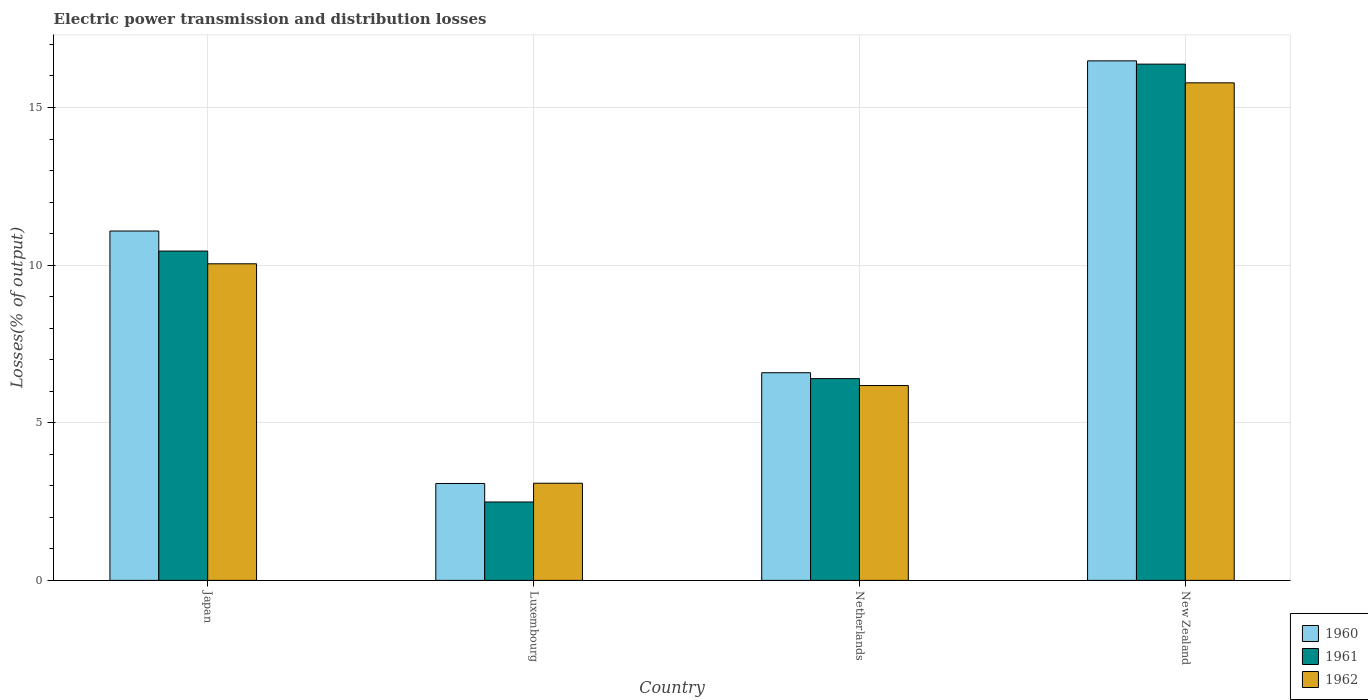How many different coloured bars are there?
Provide a short and direct response. 3. Are the number of bars per tick equal to the number of legend labels?
Your answer should be very brief. Yes. Are the number of bars on each tick of the X-axis equal?
Provide a short and direct response. Yes. How many bars are there on the 3rd tick from the left?
Your answer should be very brief. 3. How many bars are there on the 1st tick from the right?
Provide a short and direct response. 3. What is the label of the 2nd group of bars from the left?
Give a very brief answer. Luxembourg. What is the electric power transmission and distribution losses in 1960 in Japan?
Make the answer very short. 11.08. Across all countries, what is the maximum electric power transmission and distribution losses in 1962?
Offer a terse response. 15.78. Across all countries, what is the minimum electric power transmission and distribution losses in 1961?
Your answer should be compact. 2.49. In which country was the electric power transmission and distribution losses in 1962 maximum?
Your answer should be compact. New Zealand. In which country was the electric power transmission and distribution losses in 1962 minimum?
Keep it short and to the point. Luxembourg. What is the total electric power transmission and distribution losses in 1961 in the graph?
Give a very brief answer. 35.71. What is the difference between the electric power transmission and distribution losses in 1960 in Luxembourg and that in Netherlands?
Ensure brevity in your answer.  -3.51. What is the difference between the electric power transmission and distribution losses in 1961 in New Zealand and the electric power transmission and distribution losses in 1960 in Luxembourg?
Make the answer very short. 13.3. What is the average electric power transmission and distribution losses in 1961 per country?
Make the answer very short. 8.93. What is the difference between the electric power transmission and distribution losses of/in 1961 and electric power transmission and distribution losses of/in 1960 in Japan?
Give a very brief answer. -0.64. In how many countries, is the electric power transmission and distribution losses in 1961 greater than 1 %?
Ensure brevity in your answer.  4. What is the ratio of the electric power transmission and distribution losses in 1960 in Luxembourg to that in Netherlands?
Your answer should be very brief. 0.47. Is the electric power transmission and distribution losses in 1961 in Luxembourg less than that in Netherlands?
Provide a short and direct response. Yes. What is the difference between the highest and the second highest electric power transmission and distribution losses in 1961?
Provide a short and direct response. 5.93. What is the difference between the highest and the lowest electric power transmission and distribution losses in 1961?
Keep it short and to the point. 13.89. In how many countries, is the electric power transmission and distribution losses in 1960 greater than the average electric power transmission and distribution losses in 1960 taken over all countries?
Your answer should be compact. 2. Is it the case that in every country, the sum of the electric power transmission and distribution losses in 1960 and electric power transmission and distribution losses in 1962 is greater than the electric power transmission and distribution losses in 1961?
Offer a terse response. Yes. How many bars are there?
Provide a succinct answer. 12. Are all the bars in the graph horizontal?
Provide a short and direct response. No. Are the values on the major ticks of Y-axis written in scientific E-notation?
Provide a succinct answer. No. Does the graph contain grids?
Make the answer very short. Yes. Where does the legend appear in the graph?
Provide a succinct answer. Bottom right. How are the legend labels stacked?
Offer a terse response. Vertical. What is the title of the graph?
Give a very brief answer. Electric power transmission and distribution losses. What is the label or title of the X-axis?
Ensure brevity in your answer.  Country. What is the label or title of the Y-axis?
Offer a very short reply. Losses(% of output). What is the Losses(% of output) of 1960 in Japan?
Offer a terse response. 11.08. What is the Losses(% of output) of 1961 in Japan?
Make the answer very short. 10.45. What is the Losses(% of output) of 1962 in Japan?
Your response must be concise. 10.04. What is the Losses(% of output) in 1960 in Luxembourg?
Offer a very short reply. 3.07. What is the Losses(% of output) of 1961 in Luxembourg?
Give a very brief answer. 2.49. What is the Losses(% of output) of 1962 in Luxembourg?
Your answer should be compact. 3.08. What is the Losses(% of output) in 1960 in Netherlands?
Keep it short and to the point. 6.59. What is the Losses(% of output) in 1961 in Netherlands?
Give a very brief answer. 6.4. What is the Losses(% of output) in 1962 in Netherlands?
Give a very brief answer. 6.18. What is the Losses(% of output) in 1960 in New Zealand?
Give a very brief answer. 16.48. What is the Losses(% of output) in 1961 in New Zealand?
Give a very brief answer. 16.38. What is the Losses(% of output) in 1962 in New Zealand?
Your response must be concise. 15.78. Across all countries, what is the maximum Losses(% of output) in 1960?
Give a very brief answer. 16.48. Across all countries, what is the maximum Losses(% of output) of 1961?
Ensure brevity in your answer.  16.38. Across all countries, what is the maximum Losses(% of output) in 1962?
Offer a very short reply. 15.78. Across all countries, what is the minimum Losses(% of output) of 1960?
Provide a succinct answer. 3.07. Across all countries, what is the minimum Losses(% of output) in 1961?
Keep it short and to the point. 2.49. Across all countries, what is the minimum Losses(% of output) in 1962?
Your answer should be compact. 3.08. What is the total Losses(% of output) of 1960 in the graph?
Ensure brevity in your answer.  37.22. What is the total Losses(% of output) of 1961 in the graph?
Your answer should be very brief. 35.71. What is the total Losses(% of output) in 1962 in the graph?
Your answer should be compact. 35.09. What is the difference between the Losses(% of output) in 1960 in Japan and that in Luxembourg?
Your answer should be very brief. 8.01. What is the difference between the Losses(% of output) in 1961 in Japan and that in Luxembourg?
Keep it short and to the point. 7.96. What is the difference between the Losses(% of output) in 1962 in Japan and that in Luxembourg?
Your response must be concise. 6.96. What is the difference between the Losses(% of output) of 1960 in Japan and that in Netherlands?
Offer a terse response. 4.49. What is the difference between the Losses(% of output) in 1961 in Japan and that in Netherlands?
Your response must be concise. 4.05. What is the difference between the Losses(% of output) of 1962 in Japan and that in Netherlands?
Ensure brevity in your answer.  3.86. What is the difference between the Losses(% of output) in 1960 in Japan and that in New Zealand?
Offer a terse response. -5.4. What is the difference between the Losses(% of output) of 1961 in Japan and that in New Zealand?
Make the answer very short. -5.93. What is the difference between the Losses(% of output) in 1962 in Japan and that in New Zealand?
Provide a succinct answer. -5.74. What is the difference between the Losses(% of output) in 1960 in Luxembourg and that in Netherlands?
Your response must be concise. -3.51. What is the difference between the Losses(% of output) of 1961 in Luxembourg and that in Netherlands?
Offer a terse response. -3.91. What is the difference between the Losses(% of output) of 1962 in Luxembourg and that in Netherlands?
Keep it short and to the point. -3.1. What is the difference between the Losses(% of output) in 1960 in Luxembourg and that in New Zealand?
Your answer should be compact. -13.41. What is the difference between the Losses(% of output) in 1961 in Luxembourg and that in New Zealand?
Your response must be concise. -13.89. What is the difference between the Losses(% of output) of 1962 in Luxembourg and that in New Zealand?
Provide a succinct answer. -12.7. What is the difference between the Losses(% of output) in 1960 in Netherlands and that in New Zealand?
Provide a succinct answer. -9.89. What is the difference between the Losses(% of output) in 1961 in Netherlands and that in New Zealand?
Make the answer very short. -9.98. What is the difference between the Losses(% of output) in 1962 in Netherlands and that in New Zealand?
Give a very brief answer. -9.6. What is the difference between the Losses(% of output) in 1960 in Japan and the Losses(% of output) in 1961 in Luxembourg?
Provide a short and direct response. 8.6. What is the difference between the Losses(% of output) of 1960 in Japan and the Losses(% of output) of 1962 in Luxembourg?
Keep it short and to the point. 8. What is the difference between the Losses(% of output) in 1961 in Japan and the Losses(% of output) in 1962 in Luxembourg?
Your answer should be very brief. 7.36. What is the difference between the Losses(% of output) of 1960 in Japan and the Losses(% of output) of 1961 in Netherlands?
Ensure brevity in your answer.  4.68. What is the difference between the Losses(% of output) in 1960 in Japan and the Losses(% of output) in 1962 in Netherlands?
Provide a short and direct response. 4.9. What is the difference between the Losses(% of output) of 1961 in Japan and the Losses(% of output) of 1962 in Netherlands?
Give a very brief answer. 4.27. What is the difference between the Losses(% of output) in 1960 in Japan and the Losses(% of output) in 1961 in New Zealand?
Offer a very short reply. -5.29. What is the difference between the Losses(% of output) of 1960 in Japan and the Losses(% of output) of 1962 in New Zealand?
Ensure brevity in your answer.  -4.7. What is the difference between the Losses(% of output) of 1961 in Japan and the Losses(% of output) of 1962 in New Zealand?
Your answer should be very brief. -5.34. What is the difference between the Losses(% of output) of 1960 in Luxembourg and the Losses(% of output) of 1961 in Netherlands?
Give a very brief answer. -3.33. What is the difference between the Losses(% of output) in 1960 in Luxembourg and the Losses(% of output) in 1962 in Netherlands?
Offer a very short reply. -3.11. What is the difference between the Losses(% of output) of 1961 in Luxembourg and the Losses(% of output) of 1962 in Netherlands?
Your answer should be compact. -3.69. What is the difference between the Losses(% of output) in 1960 in Luxembourg and the Losses(% of output) in 1961 in New Zealand?
Provide a succinct answer. -13.3. What is the difference between the Losses(% of output) in 1960 in Luxembourg and the Losses(% of output) in 1962 in New Zealand?
Keep it short and to the point. -12.71. What is the difference between the Losses(% of output) of 1961 in Luxembourg and the Losses(% of output) of 1962 in New Zealand?
Provide a short and direct response. -13.3. What is the difference between the Losses(% of output) in 1960 in Netherlands and the Losses(% of output) in 1961 in New Zealand?
Your answer should be very brief. -9.79. What is the difference between the Losses(% of output) in 1960 in Netherlands and the Losses(% of output) in 1962 in New Zealand?
Make the answer very short. -9.2. What is the difference between the Losses(% of output) of 1961 in Netherlands and the Losses(% of output) of 1962 in New Zealand?
Provide a succinct answer. -9.38. What is the average Losses(% of output) of 1960 per country?
Your answer should be very brief. 9.31. What is the average Losses(% of output) in 1961 per country?
Make the answer very short. 8.93. What is the average Losses(% of output) of 1962 per country?
Provide a short and direct response. 8.77. What is the difference between the Losses(% of output) in 1960 and Losses(% of output) in 1961 in Japan?
Ensure brevity in your answer.  0.64. What is the difference between the Losses(% of output) in 1960 and Losses(% of output) in 1962 in Japan?
Give a very brief answer. 1.04. What is the difference between the Losses(% of output) of 1961 and Losses(% of output) of 1962 in Japan?
Your answer should be very brief. 0.4. What is the difference between the Losses(% of output) in 1960 and Losses(% of output) in 1961 in Luxembourg?
Keep it short and to the point. 0.59. What is the difference between the Losses(% of output) in 1960 and Losses(% of output) in 1962 in Luxembourg?
Offer a very short reply. -0.01. What is the difference between the Losses(% of output) in 1961 and Losses(% of output) in 1962 in Luxembourg?
Your answer should be very brief. -0.6. What is the difference between the Losses(% of output) in 1960 and Losses(% of output) in 1961 in Netherlands?
Offer a very short reply. 0.19. What is the difference between the Losses(% of output) in 1960 and Losses(% of output) in 1962 in Netherlands?
Your answer should be compact. 0.41. What is the difference between the Losses(% of output) in 1961 and Losses(% of output) in 1962 in Netherlands?
Offer a terse response. 0.22. What is the difference between the Losses(% of output) of 1960 and Losses(% of output) of 1961 in New Zealand?
Ensure brevity in your answer.  0.1. What is the difference between the Losses(% of output) in 1960 and Losses(% of output) in 1962 in New Zealand?
Ensure brevity in your answer.  0.7. What is the difference between the Losses(% of output) in 1961 and Losses(% of output) in 1962 in New Zealand?
Provide a succinct answer. 0.59. What is the ratio of the Losses(% of output) of 1960 in Japan to that in Luxembourg?
Your answer should be very brief. 3.61. What is the ratio of the Losses(% of output) of 1961 in Japan to that in Luxembourg?
Your answer should be compact. 4.2. What is the ratio of the Losses(% of output) in 1962 in Japan to that in Luxembourg?
Ensure brevity in your answer.  3.26. What is the ratio of the Losses(% of output) in 1960 in Japan to that in Netherlands?
Give a very brief answer. 1.68. What is the ratio of the Losses(% of output) in 1961 in Japan to that in Netherlands?
Your answer should be compact. 1.63. What is the ratio of the Losses(% of output) in 1962 in Japan to that in Netherlands?
Provide a succinct answer. 1.62. What is the ratio of the Losses(% of output) in 1960 in Japan to that in New Zealand?
Provide a short and direct response. 0.67. What is the ratio of the Losses(% of output) in 1961 in Japan to that in New Zealand?
Provide a short and direct response. 0.64. What is the ratio of the Losses(% of output) of 1962 in Japan to that in New Zealand?
Offer a terse response. 0.64. What is the ratio of the Losses(% of output) in 1960 in Luxembourg to that in Netherlands?
Your answer should be very brief. 0.47. What is the ratio of the Losses(% of output) of 1961 in Luxembourg to that in Netherlands?
Provide a short and direct response. 0.39. What is the ratio of the Losses(% of output) of 1962 in Luxembourg to that in Netherlands?
Your response must be concise. 0.5. What is the ratio of the Losses(% of output) in 1960 in Luxembourg to that in New Zealand?
Give a very brief answer. 0.19. What is the ratio of the Losses(% of output) in 1961 in Luxembourg to that in New Zealand?
Keep it short and to the point. 0.15. What is the ratio of the Losses(% of output) of 1962 in Luxembourg to that in New Zealand?
Offer a very short reply. 0.2. What is the ratio of the Losses(% of output) in 1960 in Netherlands to that in New Zealand?
Keep it short and to the point. 0.4. What is the ratio of the Losses(% of output) of 1961 in Netherlands to that in New Zealand?
Make the answer very short. 0.39. What is the ratio of the Losses(% of output) of 1962 in Netherlands to that in New Zealand?
Your answer should be compact. 0.39. What is the difference between the highest and the second highest Losses(% of output) in 1960?
Make the answer very short. 5.4. What is the difference between the highest and the second highest Losses(% of output) in 1961?
Provide a succinct answer. 5.93. What is the difference between the highest and the second highest Losses(% of output) in 1962?
Offer a terse response. 5.74. What is the difference between the highest and the lowest Losses(% of output) of 1960?
Give a very brief answer. 13.41. What is the difference between the highest and the lowest Losses(% of output) of 1961?
Ensure brevity in your answer.  13.89. What is the difference between the highest and the lowest Losses(% of output) in 1962?
Ensure brevity in your answer.  12.7. 